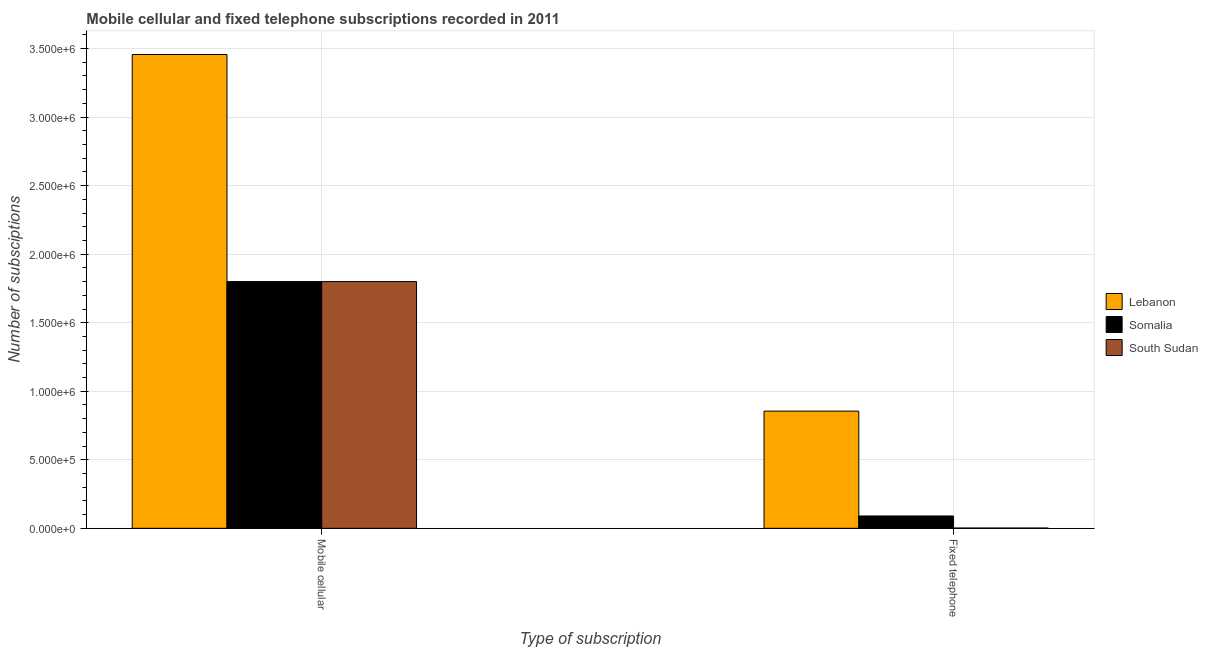How many bars are there on the 2nd tick from the left?
Provide a short and direct response. 3. How many bars are there on the 1st tick from the right?
Make the answer very short. 3. What is the label of the 1st group of bars from the left?
Your answer should be very brief. Mobile cellular. What is the number of mobile cellular subscriptions in Somalia?
Your answer should be compact. 1.80e+06. Across all countries, what is the maximum number of fixed telephone subscriptions?
Provide a short and direct response. 8.55e+05. Across all countries, what is the minimum number of mobile cellular subscriptions?
Your answer should be compact. 1.80e+06. In which country was the number of fixed telephone subscriptions maximum?
Offer a terse response. Lebanon. In which country was the number of mobile cellular subscriptions minimum?
Give a very brief answer. Somalia. What is the total number of fixed telephone subscriptions in the graph?
Your answer should be compact. 9.47e+05. What is the difference between the number of fixed telephone subscriptions in Lebanon and that in Somalia?
Ensure brevity in your answer.  7.65e+05. What is the difference between the number of mobile cellular subscriptions in South Sudan and the number of fixed telephone subscriptions in Lebanon?
Your response must be concise. 9.45e+05. What is the average number of fixed telephone subscriptions per country?
Make the answer very short. 3.16e+05. What is the difference between the number of fixed telephone subscriptions and number of mobile cellular subscriptions in South Sudan?
Provide a succinct answer. -1.80e+06. What is the ratio of the number of fixed telephone subscriptions in Lebanon to that in South Sudan?
Ensure brevity in your answer.  388.64. Is the number of mobile cellular subscriptions in Somalia less than that in South Sudan?
Your answer should be compact. No. What does the 3rd bar from the left in Fixed telephone represents?
Make the answer very short. South Sudan. What does the 3rd bar from the right in Fixed telephone represents?
Give a very brief answer. Lebanon. What is the difference between two consecutive major ticks on the Y-axis?
Keep it short and to the point. 5.00e+05. Are the values on the major ticks of Y-axis written in scientific E-notation?
Offer a very short reply. Yes. How are the legend labels stacked?
Keep it short and to the point. Vertical. What is the title of the graph?
Your answer should be very brief. Mobile cellular and fixed telephone subscriptions recorded in 2011. Does "Argentina" appear as one of the legend labels in the graph?
Your answer should be very brief. No. What is the label or title of the X-axis?
Provide a short and direct response. Type of subscription. What is the label or title of the Y-axis?
Ensure brevity in your answer.  Number of subsciptions. What is the Number of subsciptions of Lebanon in Mobile cellular?
Offer a terse response. 3.46e+06. What is the Number of subsciptions in Somalia in Mobile cellular?
Keep it short and to the point. 1.80e+06. What is the Number of subsciptions in South Sudan in Mobile cellular?
Offer a terse response. 1.80e+06. What is the Number of subsciptions in Lebanon in Fixed telephone?
Ensure brevity in your answer.  8.55e+05. What is the Number of subsciptions of South Sudan in Fixed telephone?
Your answer should be compact. 2200. Across all Type of subscription, what is the maximum Number of subsciptions in Lebanon?
Offer a very short reply. 3.46e+06. Across all Type of subscription, what is the maximum Number of subsciptions of Somalia?
Give a very brief answer. 1.80e+06. Across all Type of subscription, what is the maximum Number of subsciptions of South Sudan?
Your answer should be compact. 1.80e+06. Across all Type of subscription, what is the minimum Number of subsciptions in Lebanon?
Make the answer very short. 8.55e+05. Across all Type of subscription, what is the minimum Number of subsciptions of Somalia?
Make the answer very short. 9.00e+04. Across all Type of subscription, what is the minimum Number of subsciptions of South Sudan?
Offer a very short reply. 2200. What is the total Number of subsciptions in Lebanon in the graph?
Give a very brief answer. 4.31e+06. What is the total Number of subsciptions in Somalia in the graph?
Your response must be concise. 1.89e+06. What is the total Number of subsciptions in South Sudan in the graph?
Give a very brief answer. 1.80e+06. What is the difference between the Number of subsciptions of Lebanon in Mobile cellular and that in Fixed telephone?
Your answer should be compact. 2.60e+06. What is the difference between the Number of subsciptions of Somalia in Mobile cellular and that in Fixed telephone?
Provide a succinct answer. 1.71e+06. What is the difference between the Number of subsciptions of South Sudan in Mobile cellular and that in Fixed telephone?
Your answer should be very brief. 1.80e+06. What is the difference between the Number of subsciptions of Lebanon in Mobile cellular and the Number of subsciptions of Somalia in Fixed telephone?
Your answer should be compact. 3.37e+06. What is the difference between the Number of subsciptions of Lebanon in Mobile cellular and the Number of subsciptions of South Sudan in Fixed telephone?
Your response must be concise. 3.45e+06. What is the difference between the Number of subsciptions in Somalia in Mobile cellular and the Number of subsciptions in South Sudan in Fixed telephone?
Your response must be concise. 1.80e+06. What is the average Number of subsciptions of Lebanon per Type of subscription?
Make the answer very short. 2.16e+06. What is the average Number of subsciptions of Somalia per Type of subscription?
Offer a terse response. 9.45e+05. What is the average Number of subsciptions of South Sudan per Type of subscription?
Ensure brevity in your answer.  9.01e+05. What is the difference between the Number of subsciptions of Lebanon and Number of subsciptions of Somalia in Mobile cellular?
Offer a terse response. 1.66e+06. What is the difference between the Number of subsciptions in Lebanon and Number of subsciptions in South Sudan in Mobile cellular?
Your response must be concise. 1.66e+06. What is the difference between the Number of subsciptions of Lebanon and Number of subsciptions of Somalia in Fixed telephone?
Give a very brief answer. 7.65e+05. What is the difference between the Number of subsciptions in Lebanon and Number of subsciptions in South Sudan in Fixed telephone?
Make the answer very short. 8.53e+05. What is the difference between the Number of subsciptions of Somalia and Number of subsciptions of South Sudan in Fixed telephone?
Your response must be concise. 8.78e+04. What is the ratio of the Number of subsciptions of Lebanon in Mobile cellular to that in Fixed telephone?
Your answer should be compact. 4.04. What is the ratio of the Number of subsciptions of Somalia in Mobile cellular to that in Fixed telephone?
Your answer should be very brief. 20. What is the ratio of the Number of subsciptions of South Sudan in Mobile cellular to that in Fixed telephone?
Make the answer very short. 818.18. What is the difference between the highest and the second highest Number of subsciptions in Lebanon?
Ensure brevity in your answer.  2.60e+06. What is the difference between the highest and the second highest Number of subsciptions of Somalia?
Offer a terse response. 1.71e+06. What is the difference between the highest and the second highest Number of subsciptions of South Sudan?
Provide a succinct answer. 1.80e+06. What is the difference between the highest and the lowest Number of subsciptions of Lebanon?
Offer a terse response. 2.60e+06. What is the difference between the highest and the lowest Number of subsciptions of Somalia?
Give a very brief answer. 1.71e+06. What is the difference between the highest and the lowest Number of subsciptions in South Sudan?
Give a very brief answer. 1.80e+06. 